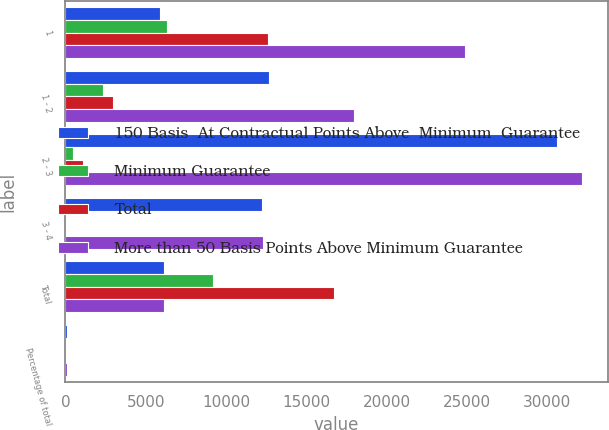Convert chart to OTSL. <chart><loc_0><loc_0><loc_500><loc_500><stacked_bar_chart><ecel><fcel>1<fcel>1 - 2<fcel>2 - 3<fcel>3 - 4<fcel>Total<fcel>Percentage of total<nl><fcel>150 Basis  At Contractual Points Above  Minimum  Guarantee<fcel>5896<fcel>12659<fcel>30611<fcel>12231<fcel>6118<fcel>73<nl><fcel>Minimum Guarantee<fcel>6340<fcel>2341<fcel>473<fcel>50<fcel>9204<fcel>10<nl><fcel>Total<fcel>12635<fcel>2974<fcel>1067<fcel>10<fcel>16695<fcel>17<nl><fcel>More than 50 Basis Points Above Minimum Guarantee<fcel>24871<fcel>17974<fcel>32151<fcel>12291<fcel>6118<fcel>100<nl></chart> 